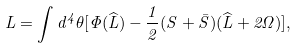Convert formula to latex. <formula><loc_0><loc_0><loc_500><loc_500>L = \int d ^ { 4 } \theta [ \Phi ( \widehat { L } ) - \frac { 1 } { 2 } ( S + \bar { S } ) ( \widehat { L } + 2 \Omega ) ] ,</formula> 